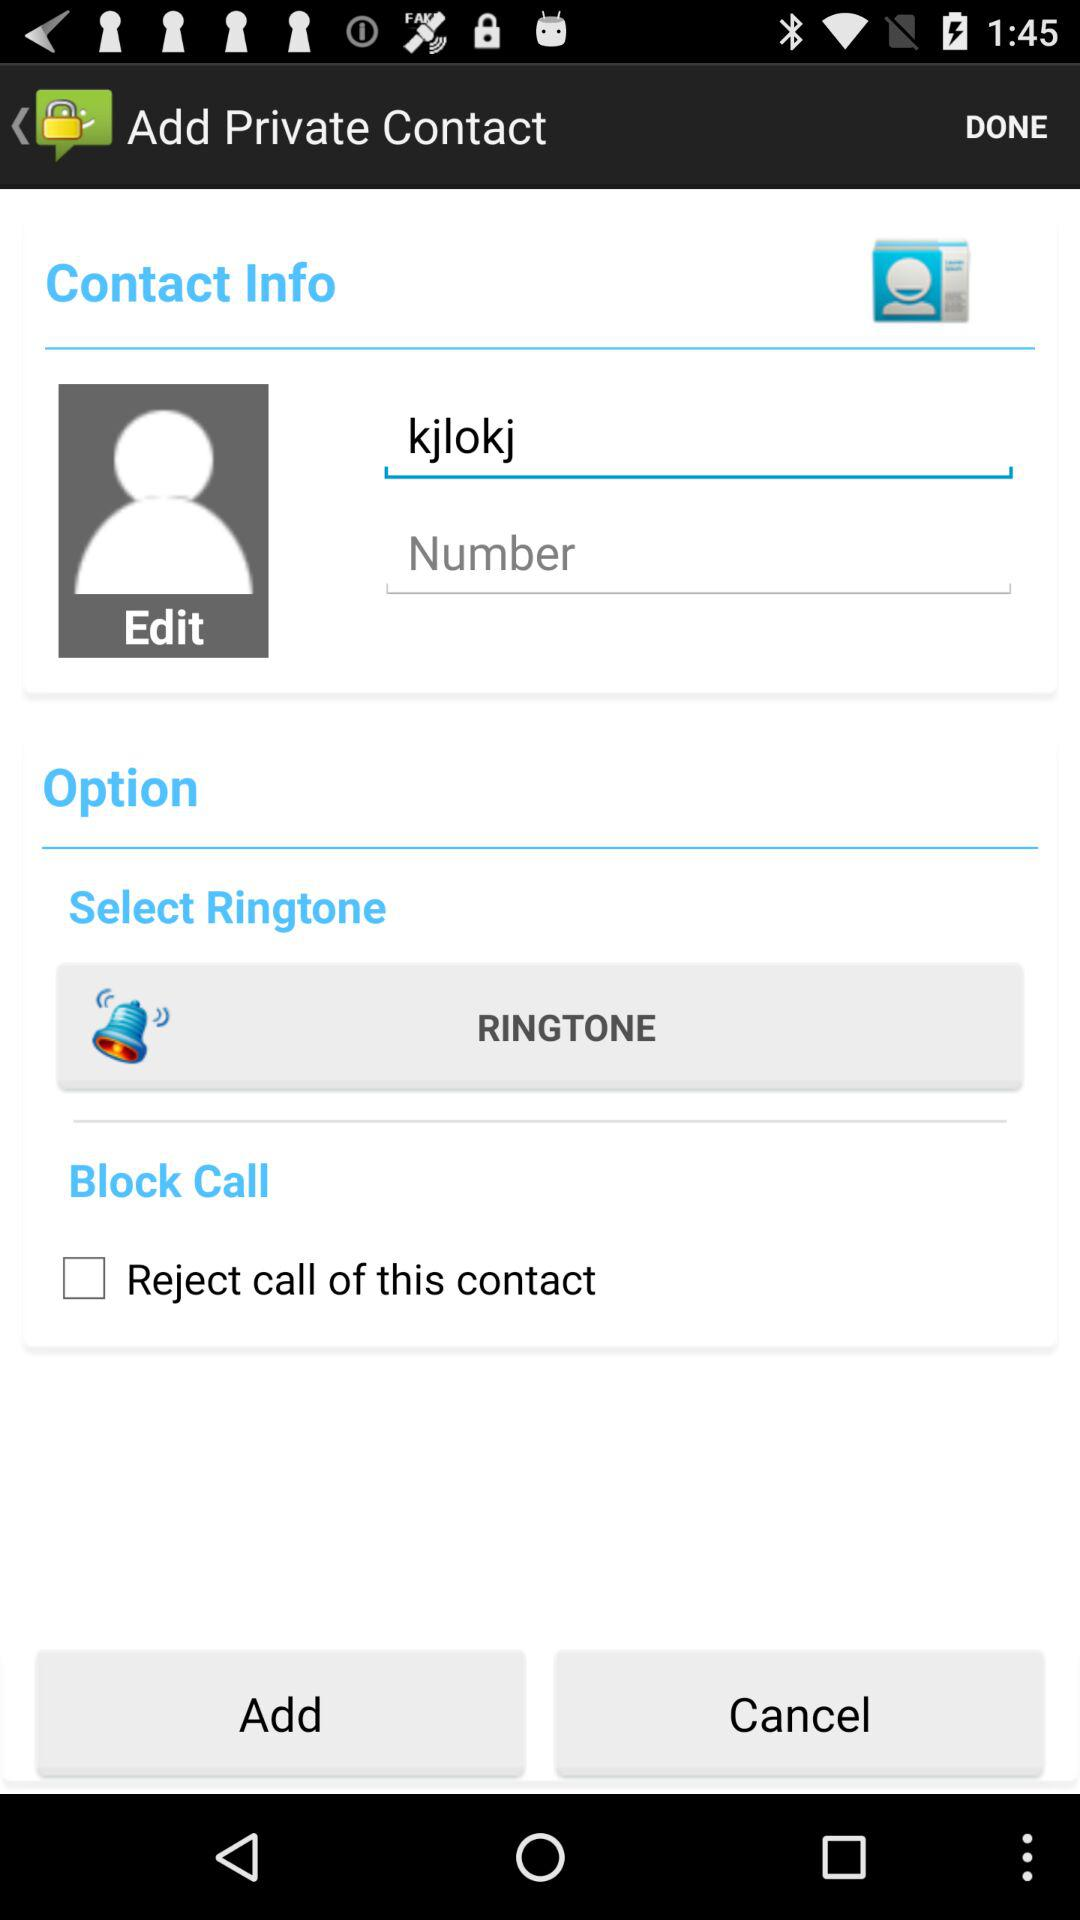What's the status of "Reject call of this contact" in "Block Call"? The status is "off". 